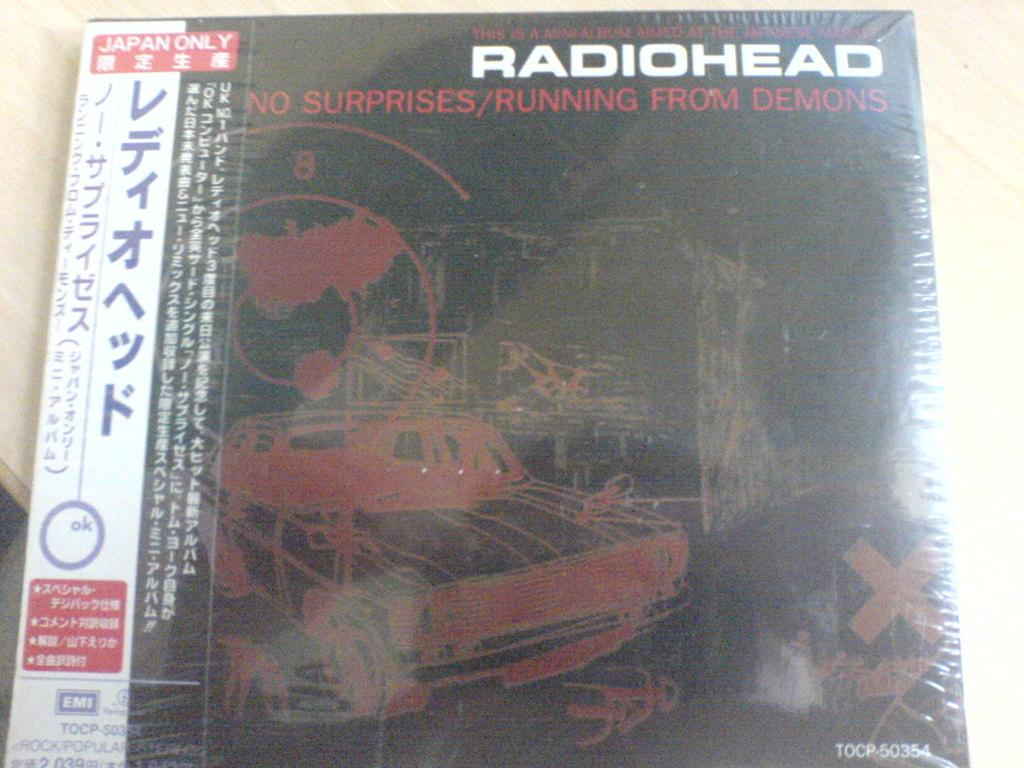What object is present in the image? There is a book in the image. What language is written on the book? The book has Japanese text on it. Where is the book located? The book is on a table. What type of flesh can be seen on the cover of the book? There is no flesh visible on the cover of the book; it has Japanese text on it. 